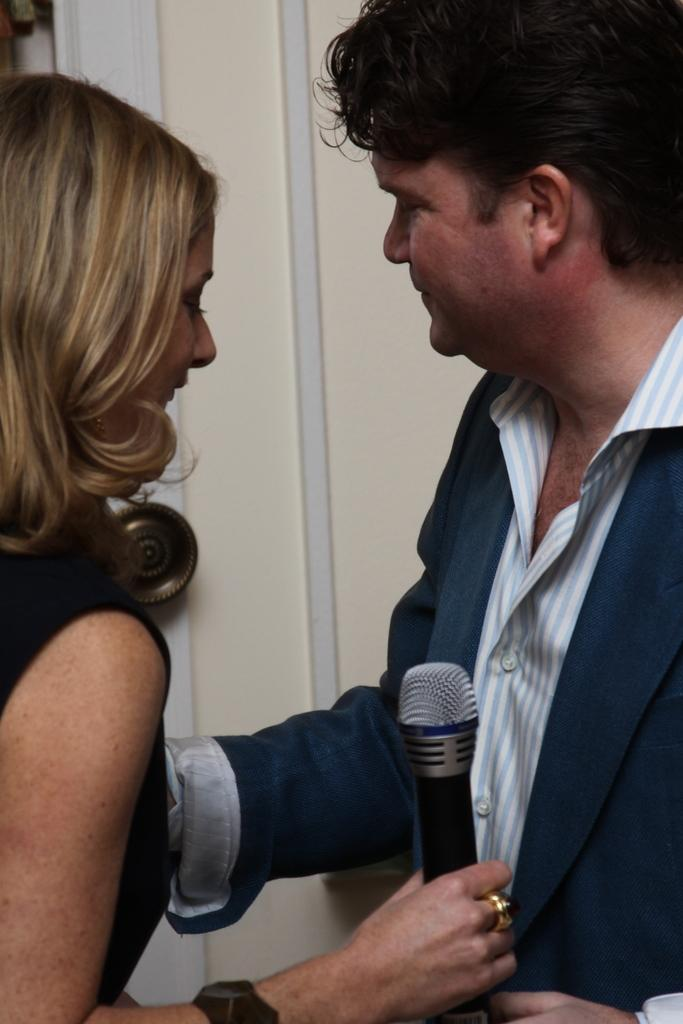What are the two people in the image? There is a man and a woman in the image. What is the woman holding in the image? The woman is holding a microphone. What direction is the skate moving in the image? There is no skate present in the image. How can we tell if the image is quiet or not? The image itself is silent, but we cannot determine the level of noise or quietness in the depicted scene without additional context or information. 